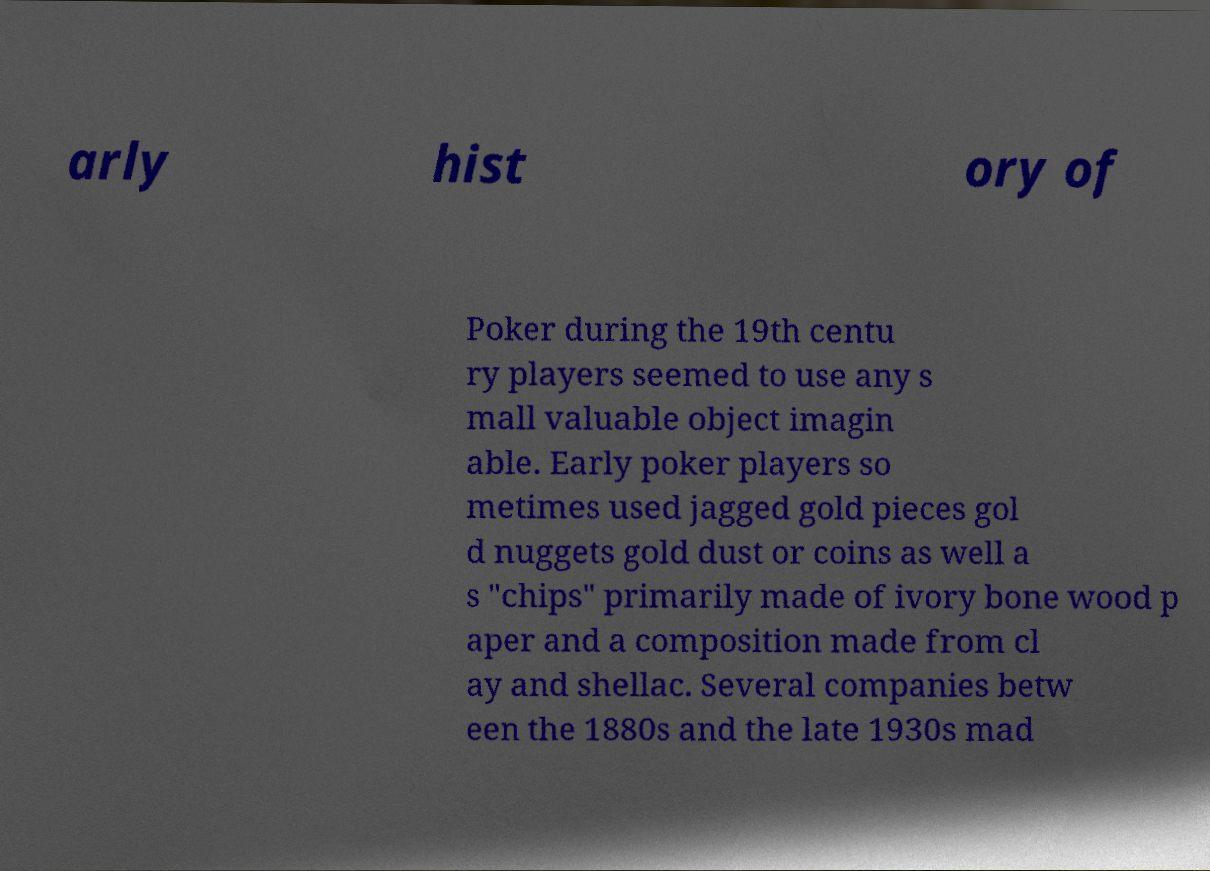For documentation purposes, I need the text within this image transcribed. Could you provide that? arly hist ory of Poker during the 19th centu ry players seemed to use any s mall valuable object imagin able. Early poker players so metimes used jagged gold pieces gol d nuggets gold dust or coins as well a s "chips" primarily made of ivory bone wood p aper and a composition made from cl ay and shellac. Several companies betw een the 1880s and the late 1930s mad 